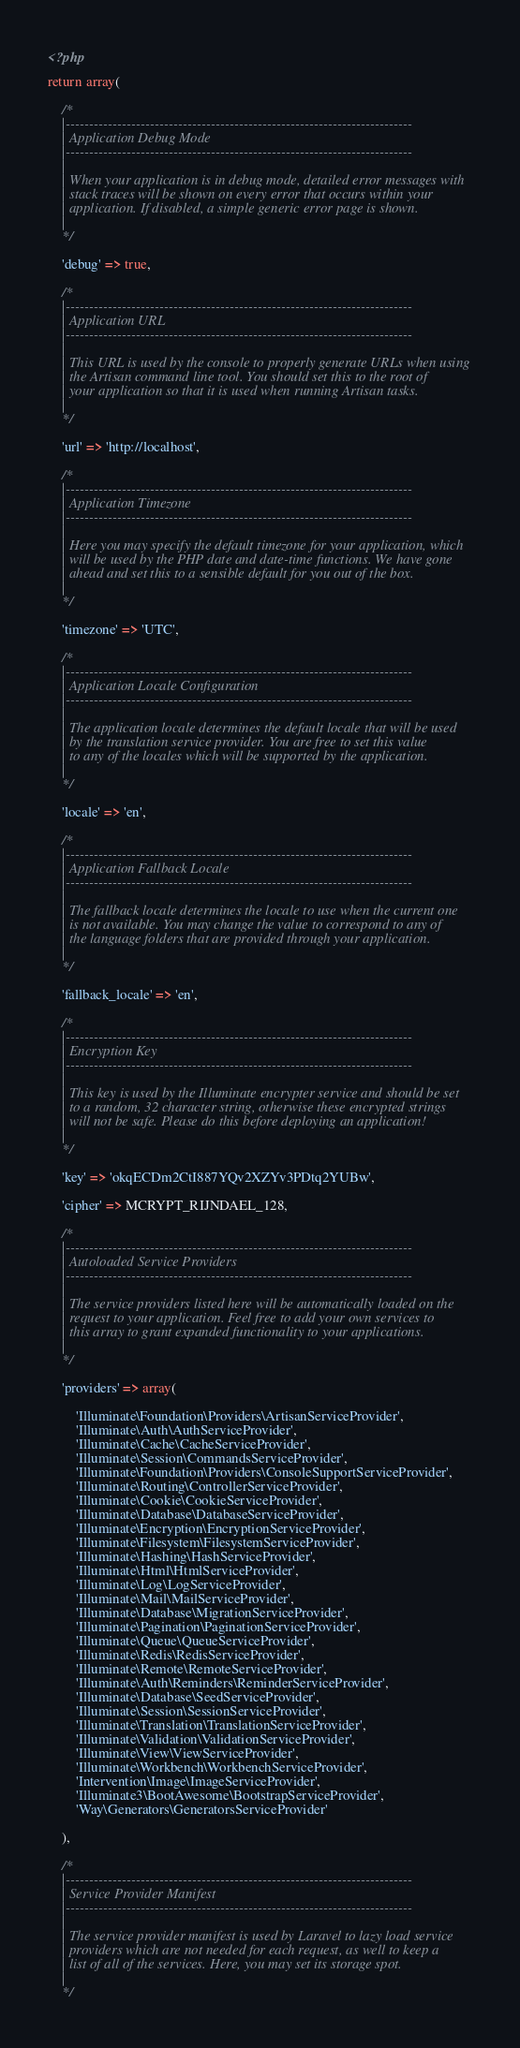<code> <loc_0><loc_0><loc_500><loc_500><_PHP_><?php

return array(

	/*
	|--------------------------------------------------------------------------
	| Application Debug Mode
	|--------------------------------------------------------------------------
	|
	| When your application is in debug mode, detailed error messages with
	| stack traces will be shown on every error that occurs within your
	| application. If disabled, a simple generic error page is shown.
	|
	*/

	'debug' => true,

	/*
	|--------------------------------------------------------------------------
	| Application URL
	|--------------------------------------------------------------------------
	|
	| This URL is used by the console to properly generate URLs when using
	| the Artisan command line tool. You should set this to the root of
	| your application so that it is used when running Artisan tasks.
	|
	*/

	'url' => 'http://localhost',

	/*
	|--------------------------------------------------------------------------
	| Application Timezone
	|--------------------------------------------------------------------------
	|
	| Here you may specify the default timezone for your application, which
	| will be used by the PHP date and date-time functions. We have gone
	| ahead and set this to a sensible default for you out of the box.
	|
	*/

	'timezone' => 'UTC',

	/*
	|--------------------------------------------------------------------------
	| Application Locale Configuration
	|--------------------------------------------------------------------------
	|
	| The application locale determines the default locale that will be used
	| by the translation service provider. You are free to set this value
	| to any of the locales which will be supported by the application.
	|
	*/

	'locale' => 'en',

	/*
	|--------------------------------------------------------------------------
	| Application Fallback Locale
	|--------------------------------------------------------------------------
	|
	| The fallback locale determines the locale to use when the current one
	| is not available. You may change the value to correspond to any of
	| the language folders that are provided through your application.
	|
	*/

	'fallback_locale' => 'en',

	/*
	|--------------------------------------------------------------------------
	| Encryption Key
	|--------------------------------------------------------------------------
	|
	| This key is used by the Illuminate encrypter service and should be set
	| to a random, 32 character string, otherwise these encrypted strings
	| will not be safe. Please do this before deploying an application!
	|
	*/

	'key' => 'okqECDm2CtI887YQv2XZYv3PDtq2YUBw',

	'cipher' => MCRYPT_RIJNDAEL_128,

	/*
	|--------------------------------------------------------------------------
	| Autoloaded Service Providers
	|--------------------------------------------------------------------------
	|
	| The service providers listed here will be automatically loaded on the
	| request to your application. Feel free to add your own services to
	| this array to grant expanded functionality to your applications.
	|
	*/

	'providers' => array(

		'Illuminate\Foundation\Providers\ArtisanServiceProvider',
		'Illuminate\Auth\AuthServiceProvider',
		'Illuminate\Cache\CacheServiceProvider',
		'Illuminate\Session\CommandsServiceProvider',
		'Illuminate\Foundation\Providers\ConsoleSupportServiceProvider',
		'Illuminate\Routing\ControllerServiceProvider',
		'Illuminate\Cookie\CookieServiceProvider',
		'Illuminate\Database\DatabaseServiceProvider',
		'Illuminate\Encryption\EncryptionServiceProvider',
		'Illuminate\Filesystem\FilesystemServiceProvider',
		'Illuminate\Hashing\HashServiceProvider',
		'Illuminate\Html\HtmlServiceProvider',
		'Illuminate\Log\LogServiceProvider',
		'Illuminate\Mail\MailServiceProvider',
		'Illuminate\Database\MigrationServiceProvider',
		'Illuminate\Pagination\PaginationServiceProvider',
		'Illuminate\Queue\QueueServiceProvider',
		'Illuminate\Redis\RedisServiceProvider',
		'Illuminate\Remote\RemoteServiceProvider',
		'Illuminate\Auth\Reminders\ReminderServiceProvider',
		'Illuminate\Database\SeedServiceProvider',
		'Illuminate\Session\SessionServiceProvider',
		'Illuminate\Translation\TranslationServiceProvider',
		'Illuminate\Validation\ValidationServiceProvider',
		'Illuminate\View\ViewServiceProvider',
		'Illuminate\Workbench\WorkbenchServiceProvider',
        'Intervention\Image\ImageServiceProvider',
        'Illuminate3\BootAwesome\BootstrapServiceProvider',
        'Way\Generators\GeneratorsServiceProvider'

	),

	/*
	|--------------------------------------------------------------------------
	| Service Provider Manifest
	|--------------------------------------------------------------------------
	|
	| The service provider manifest is used by Laravel to lazy load service
	| providers which are not needed for each request, as well to keep a
	| list of all of the services. Here, you may set its storage spot.
	|
	*/
</code> 